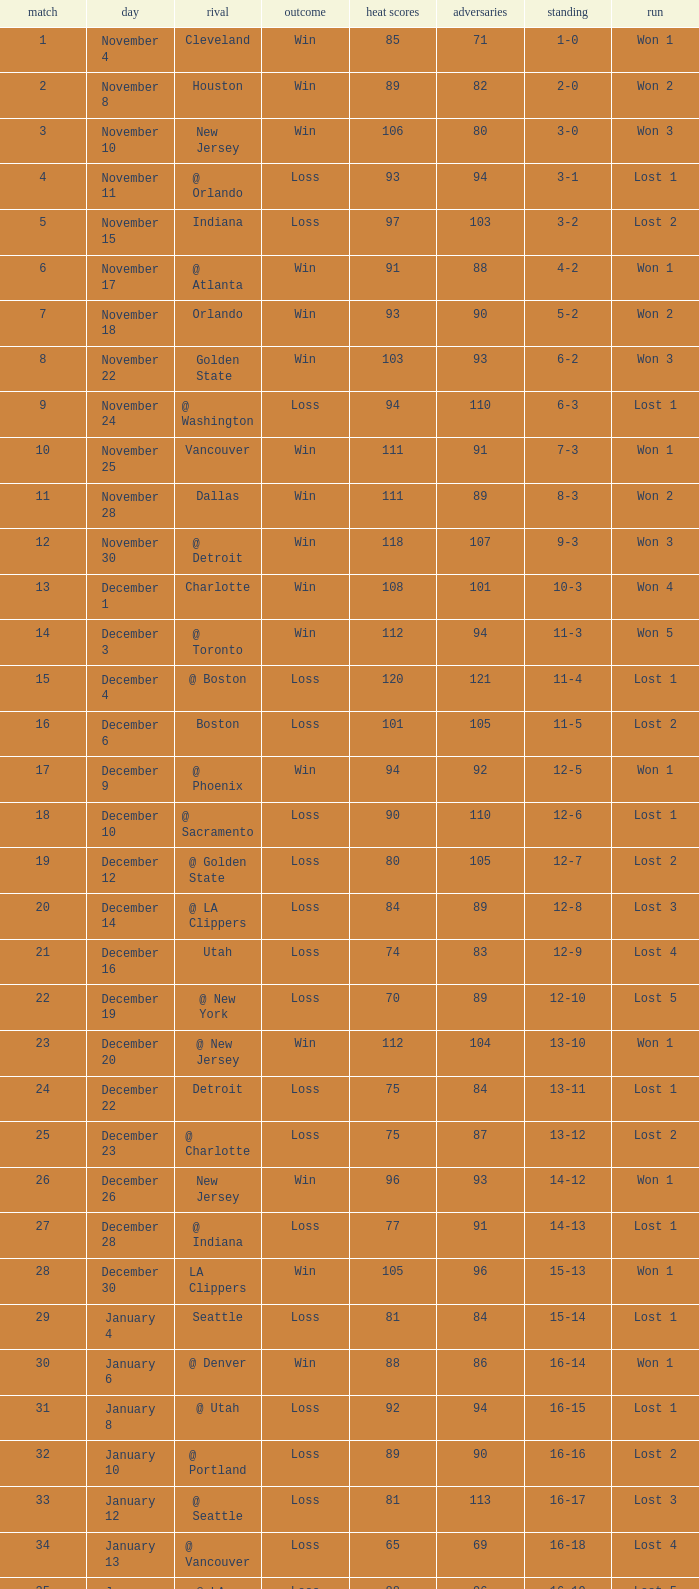What is Streak, when Heat Points is "101", and when Game is "16"? Lost 2. 